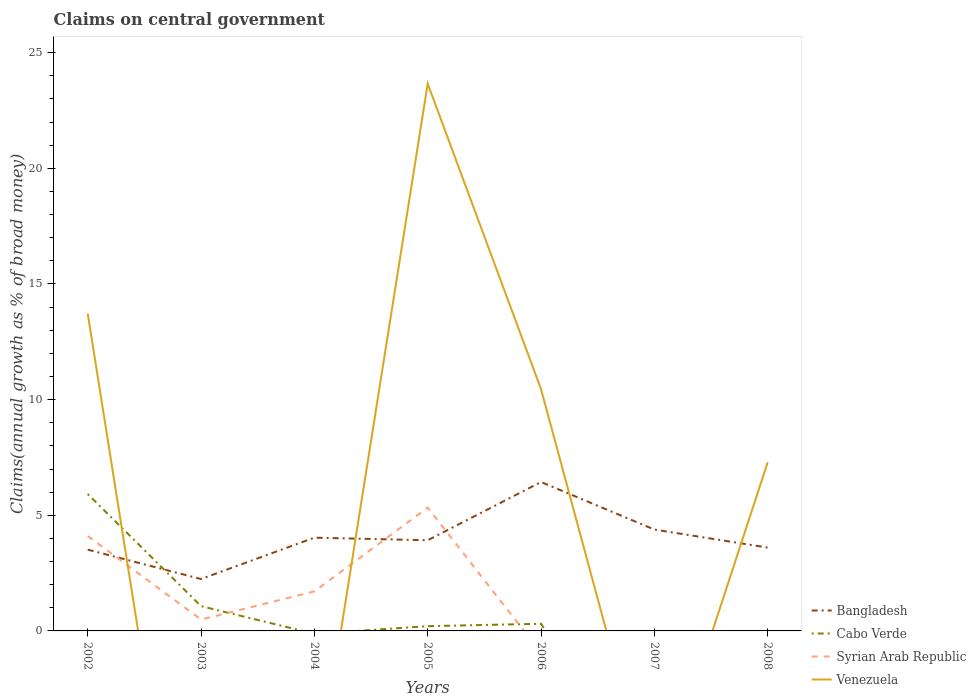How many different coloured lines are there?
Provide a succinct answer. 4. What is the total percentage of broad money claimed on centeral government in Venezuela in the graph?
Provide a succinct answer. 3.16. What is the difference between the highest and the second highest percentage of broad money claimed on centeral government in Venezuela?
Provide a succinct answer. 23.66. What is the difference between the highest and the lowest percentage of broad money claimed on centeral government in Venezuela?
Keep it short and to the point. 3. Is the percentage of broad money claimed on centeral government in Venezuela strictly greater than the percentage of broad money claimed on centeral government in Bangladesh over the years?
Provide a succinct answer. No. How many years are there in the graph?
Offer a terse response. 7. What is the difference between two consecutive major ticks on the Y-axis?
Give a very brief answer. 5. Does the graph contain any zero values?
Offer a terse response. Yes. How many legend labels are there?
Ensure brevity in your answer.  4. How are the legend labels stacked?
Your answer should be very brief. Vertical. What is the title of the graph?
Your response must be concise. Claims on central government. What is the label or title of the Y-axis?
Provide a short and direct response. Claims(annual growth as % of broad money). What is the Claims(annual growth as % of broad money) of Bangladesh in 2002?
Provide a succinct answer. 3.51. What is the Claims(annual growth as % of broad money) in Cabo Verde in 2002?
Your answer should be very brief. 5.92. What is the Claims(annual growth as % of broad money) in Syrian Arab Republic in 2002?
Provide a succinct answer. 4.1. What is the Claims(annual growth as % of broad money) in Venezuela in 2002?
Provide a succinct answer. 13.72. What is the Claims(annual growth as % of broad money) of Bangladesh in 2003?
Provide a succinct answer. 2.24. What is the Claims(annual growth as % of broad money) of Cabo Verde in 2003?
Your response must be concise. 1.07. What is the Claims(annual growth as % of broad money) in Syrian Arab Republic in 2003?
Offer a very short reply. 0.49. What is the Claims(annual growth as % of broad money) of Venezuela in 2003?
Provide a short and direct response. 0. What is the Claims(annual growth as % of broad money) in Bangladesh in 2004?
Provide a succinct answer. 4.03. What is the Claims(annual growth as % of broad money) of Syrian Arab Republic in 2004?
Your answer should be very brief. 1.71. What is the Claims(annual growth as % of broad money) of Venezuela in 2004?
Keep it short and to the point. 0. What is the Claims(annual growth as % of broad money) of Bangladesh in 2005?
Give a very brief answer. 3.92. What is the Claims(annual growth as % of broad money) of Cabo Verde in 2005?
Your answer should be compact. 0.21. What is the Claims(annual growth as % of broad money) in Syrian Arab Republic in 2005?
Provide a succinct answer. 5.33. What is the Claims(annual growth as % of broad money) of Venezuela in 2005?
Ensure brevity in your answer.  23.66. What is the Claims(annual growth as % of broad money) of Bangladesh in 2006?
Offer a terse response. 6.44. What is the Claims(annual growth as % of broad money) of Cabo Verde in 2006?
Provide a succinct answer. 0.31. What is the Claims(annual growth as % of broad money) of Venezuela in 2006?
Offer a very short reply. 10.45. What is the Claims(annual growth as % of broad money) of Bangladesh in 2007?
Your answer should be compact. 4.38. What is the Claims(annual growth as % of broad money) of Cabo Verde in 2007?
Your answer should be compact. 0. What is the Claims(annual growth as % of broad money) in Venezuela in 2007?
Provide a short and direct response. 0. What is the Claims(annual growth as % of broad money) of Bangladesh in 2008?
Make the answer very short. 3.6. What is the Claims(annual growth as % of broad money) in Syrian Arab Republic in 2008?
Your answer should be very brief. 0. What is the Claims(annual growth as % of broad money) of Venezuela in 2008?
Give a very brief answer. 7.29. Across all years, what is the maximum Claims(annual growth as % of broad money) of Bangladesh?
Ensure brevity in your answer.  6.44. Across all years, what is the maximum Claims(annual growth as % of broad money) in Cabo Verde?
Provide a short and direct response. 5.92. Across all years, what is the maximum Claims(annual growth as % of broad money) of Syrian Arab Republic?
Provide a short and direct response. 5.33. Across all years, what is the maximum Claims(annual growth as % of broad money) in Venezuela?
Make the answer very short. 23.66. Across all years, what is the minimum Claims(annual growth as % of broad money) of Bangladesh?
Your answer should be compact. 2.24. Across all years, what is the minimum Claims(annual growth as % of broad money) in Venezuela?
Keep it short and to the point. 0. What is the total Claims(annual growth as % of broad money) in Bangladesh in the graph?
Provide a succinct answer. 28.13. What is the total Claims(annual growth as % of broad money) in Cabo Verde in the graph?
Ensure brevity in your answer.  7.5. What is the total Claims(annual growth as % of broad money) of Syrian Arab Republic in the graph?
Your response must be concise. 11.63. What is the total Claims(annual growth as % of broad money) of Venezuela in the graph?
Keep it short and to the point. 55.12. What is the difference between the Claims(annual growth as % of broad money) in Bangladesh in 2002 and that in 2003?
Provide a succinct answer. 1.27. What is the difference between the Claims(annual growth as % of broad money) in Cabo Verde in 2002 and that in 2003?
Provide a short and direct response. 4.85. What is the difference between the Claims(annual growth as % of broad money) in Syrian Arab Republic in 2002 and that in 2003?
Ensure brevity in your answer.  3.61. What is the difference between the Claims(annual growth as % of broad money) of Bangladesh in 2002 and that in 2004?
Offer a terse response. -0.52. What is the difference between the Claims(annual growth as % of broad money) in Syrian Arab Republic in 2002 and that in 2004?
Your response must be concise. 2.4. What is the difference between the Claims(annual growth as % of broad money) in Bangladesh in 2002 and that in 2005?
Your answer should be very brief. -0.41. What is the difference between the Claims(annual growth as % of broad money) of Cabo Verde in 2002 and that in 2005?
Provide a succinct answer. 5.71. What is the difference between the Claims(annual growth as % of broad money) in Syrian Arab Republic in 2002 and that in 2005?
Your response must be concise. -1.23. What is the difference between the Claims(annual growth as % of broad money) of Venezuela in 2002 and that in 2005?
Offer a very short reply. -9.94. What is the difference between the Claims(annual growth as % of broad money) in Bangladesh in 2002 and that in 2006?
Offer a very short reply. -2.93. What is the difference between the Claims(annual growth as % of broad money) in Cabo Verde in 2002 and that in 2006?
Provide a short and direct response. 5.61. What is the difference between the Claims(annual growth as % of broad money) in Venezuela in 2002 and that in 2006?
Your answer should be compact. 3.27. What is the difference between the Claims(annual growth as % of broad money) of Bangladesh in 2002 and that in 2007?
Ensure brevity in your answer.  -0.87. What is the difference between the Claims(annual growth as % of broad money) in Bangladesh in 2002 and that in 2008?
Give a very brief answer. -0.09. What is the difference between the Claims(annual growth as % of broad money) in Venezuela in 2002 and that in 2008?
Ensure brevity in your answer.  6.43. What is the difference between the Claims(annual growth as % of broad money) in Bangladesh in 2003 and that in 2004?
Ensure brevity in your answer.  -1.79. What is the difference between the Claims(annual growth as % of broad money) in Syrian Arab Republic in 2003 and that in 2004?
Your answer should be very brief. -1.22. What is the difference between the Claims(annual growth as % of broad money) in Bangladesh in 2003 and that in 2005?
Give a very brief answer. -1.68. What is the difference between the Claims(annual growth as % of broad money) in Cabo Verde in 2003 and that in 2005?
Keep it short and to the point. 0.87. What is the difference between the Claims(annual growth as % of broad money) of Syrian Arab Republic in 2003 and that in 2005?
Your answer should be very brief. -4.84. What is the difference between the Claims(annual growth as % of broad money) of Bangladesh in 2003 and that in 2006?
Keep it short and to the point. -4.19. What is the difference between the Claims(annual growth as % of broad money) in Cabo Verde in 2003 and that in 2006?
Keep it short and to the point. 0.76. What is the difference between the Claims(annual growth as % of broad money) in Bangladesh in 2003 and that in 2007?
Ensure brevity in your answer.  -2.14. What is the difference between the Claims(annual growth as % of broad money) in Bangladesh in 2003 and that in 2008?
Provide a succinct answer. -1.36. What is the difference between the Claims(annual growth as % of broad money) in Bangladesh in 2004 and that in 2005?
Keep it short and to the point. 0.11. What is the difference between the Claims(annual growth as % of broad money) in Syrian Arab Republic in 2004 and that in 2005?
Offer a very short reply. -3.62. What is the difference between the Claims(annual growth as % of broad money) of Bangladesh in 2004 and that in 2006?
Provide a short and direct response. -2.41. What is the difference between the Claims(annual growth as % of broad money) in Bangladesh in 2004 and that in 2007?
Offer a very short reply. -0.35. What is the difference between the Claims(annual growth as % of broad money) of Bangladesh in 2004 and that in 2008?
Your answer should be compact. 0.43. What is the difference between the Claims(annual growth as % of broad money) in Bangladesh in 2005 and that in 2006?
Your answer should be very brief. -2.52. What is the difference between the Claims(annual growth as % of broad money) of Cabo Verde in 2005 and that in 2006?
Ensure brevity in your answer.  -0.1. What is the difference between the Claims(annual growth as % of broad money) of Venezuela in 2005 and that in 2006?
Offer a terse response. 13.21. What is the difference between the Claims(annual growth as % of broad money) of Bangladesh in 2005 and that in 2007?
Provide a succinct answer. -0.46. What is the difference between the Claims(annual growth as % of broad money) of Bangladesh in 2005 and that in 2008?
Offer a very short reply. 0.32. What is the difference between the Claims(annual growth as % of broad money) of Venezuela in 2005 and that in 2008?
Keep it short and to the point. 16.36. What is the difference between the Claims(annual growth as % of broad money) of Bangladesh in 2006 and that in 2007?
Keep it short and to the point. 2.06. What is the difference between the Claims(annual growth as % of broad money) of Bangladesh in 2006 and that in 2008?
Keep it short and to the point. 2.84. What is the difference between the Claims(annual growth as % of broad money) of Venezuela in 2006 and that in 2008?
Your answer should be very brief. 3.16. What is the difference between the Claims(annual growth as % of broad money) of Bangladesh in 2007 and that in 2008?
Keep it short and to the point. 0.78. What is the difference between the Claims(annual growth as % of broad money) in Bangladesh in 2002 and the Claims(annual growth as % of broad money) in Cabo Verde in 2003?
Provide a short and direct response. 2.44. What is the difference between the Claims(annual growth as % of broad money) in Bangladesh in 2002 and the Claims(annual growth as % of broad money) in Syrian Arab Republic in 2003?
Provide a short and direct response. 3.02. What is the difference between the Claims(annual growth as % of broad money) of Cabo Verde in 2002 and the Claims(annual growth as % of broad money) of Syrian Arab Republic in 2003?
Make the answer very short. 5.43. What is the difference between the Claims(annual growth as % of broad money) of Bangladesh in 2002 and the Claims(annual growth as % of broad money) of Syrian Arab Republic in 2004?
Offer a terse response. 1.8. What is the difference between the Claims(annual growth as % of broad money) in Cabo Verde in 2002 and the Claims(annual growth as % of broad money) in Syrian Arab Republic in 2004?
Offer a terse response. 4.21. What is the difference between the Claims(annual growth as % of broad money) in Bangladesh in 2002 and the Claims(annual growth as % of broad money) in Cabo Verde in 2005?
Ensure brevity in your answer.  3.31. What is the difference between the Claims(annual growth as % of broad money) in Bangladesh in 2002 and the Claims(annual growth as % of broad money) in Syrian Arab Republic in 2005?
Give a very brief answer. -1.82. What is the difference between the Claims(annual growth as % of broad money) of Bangladesh in 2002 and the Claims(annual growth as % of broad money) of Venezuela in 2005?
Your response must be concise. -20.14. What is the difference between the Claims(annual growth as % of broad money) of Cabo Verde in 2002 and the Claims(annual growth as % of broad money) of Syrian Arab Republic in 2005?
Offer a terse response. 0.59. What is the difference between the Claims(annual growth as % of broad money) in Cabo Verde in 2002 and the Claims(annual growth as % of broad money) in Venezuela in 2005?
Make the answer very short. -17.74. What is the difference between the Claims(annual growth as % of broad money) of Syrian Arab Republic in 2002 and the Claims(annual growth as % of broad money) of Venezuela in 2005?
Provide a short and direct response. -19.55. What is the difference between the Claims(annual growth as % of broad money) of Bangladesh in 2002 and the Claims(annual growth as % of broad money) of Cabo Verde in 2006?
Ensure brevity in your answer.  3.2. What is the difference between the Claims(annual growth as % of broad money) of Bangladesh in 2002 and the Claims(annual growth as % of broad money) of Venezuela in 2006?
Your response must be concise. -6.94. What is the difference between the Claims(annual growth as % of broad money) of Cabo Verde in 2002 and the Claims(annual growth as % of broad money) of Venezuela in 2006?
Ensure brevity in your answer.  -4.53. What is the difference between the Claims(annual growth as % of broad money) of Syrian Arab Republic in 2002 and the Claims(annual growth as % of broad money) of Venezuela in 2006?
Offer a very short reply. -6.35. What is the difference between the Claims(annual growth as % of broad money) in Bangladesh in 2002 and the Claims(annual growth as % of broad money) in Venezuela in 2008?
Provide a succinct answer. -3.78. What is the difference between the Claims(annual growth as % of broad money) of Cabo Verde in 2002 and the Claims(annual growth as % of broad money) of Venezuela in 2008?
Make the answer very short. -1.37. What is the difference between the Claims(annual growth as % of broad money) in Syrian Arab Republic in 2002 and the Claims(annual growth as % of broad money) in Venezuela in 2008?
Your answer should be compact. -3.19. What is the difference between the Claims(annual growth as % of broad money) in Bangladesh in 2003 and the Claims(annual growth as % of broad money) in Syrian Arab Republic in 2004?
Provide a succinct answer. 0.53. What is the difference between the Claims(annual growth as % of broad money) in Cabo Verde in 2003 and the Claims(annual growth as % of broad money) in Syrian Arab Republic in 2004?
Provide a succinct answer. -0.64. What is the difference between the Claims(annual growth as % of broad money) of Bangladesh in 2003 and the Claims(annual growth as % of broad money) of Cabo Verde in 2005?
Offer a very short reply. 2.04. What is the difference between the Claims(annual growth as % of broad money) in Bangladesh in 2003 and the Claims(annual growth as % of broad money) in Syrian Arab Republic in 2005?
Offer a terse response. -3.09. What is the difference between the Claims(annual growth as % of broad money) in Bangladesh in 2003 and the Claims(annual growth as % of broad money) in Venezuela in 2005?
Ensure brevity in your answer.  -21.41. What is the difference between the Claims(annual growth as % of broad money) in Cabo Verde in 2003 and the Claims(annual growth as % of broad money) in Syrian Arab Republic in 2005?
Your answer should be very brief. -4.26. What is the difference between the Claims(annual growth as % of broad money) in Cabo Verde in 2003 and the Claims(annual growth as % of broad money) in Venezuela in 2005?
Your answer should be very brief. -22.59. What is the difference between the Claims(annual growth as % of broad money) in Syrian Arab Republic in 2003 and the Claims(annual growth as % of broad money) in Venezuela in 2005?
Keep it short and to the point. -23.17. What is the difference between the Claims(annual growth as % of broad money) of Bangladesh in 2003 and the Claims(annual growth as % of broad money) of Cabo Verde in 2006?
Ensure brevity in your answer.  1.93. What is the difference between the Claims(annual growth as % of broad money) in Bangladesh in 2003 and the Claims(annual growth as % of broad money) in Venezuela in 2006?
Make the answer very short. -8.21. What is the difference between the Claims(annual growth as % of broad money) of Cabo Verde in 2003 and the Claims(annual growth as % of broad money) of Venezuela in 2006?
Ensure brevity in your answer.  -9.38. What is the difference between the Claims(annual growth as % of broad money) in Syrian Arab Republic in 2003 and the Claims(annual growth as % of broad money) in Venezuela in 2006?
Your answer should be compact. -9.96. What is the difference between the Claims(annual growth as % of broad money) of Bangladesh in 2003 and the Claims(annual growth as % of broad money) of Venezuela in 2008?
Your response must be concise. -5.05. What is the difference between the Claims(annual growth as % of broad money) of Cabo Verde in 2003 and the Claims(annual growth as % of broad money) of Venezuela in 2008?
Your response must be concise. -6.22. What is the difference between the Claims(annual growth as % of broad money) in Syrian Arab Republic in 2003 and the Claims(annual growth as % of broad money) in Venezuela in 2008?
Your answer should be compact. -6.8. What is the difference between the Claims(annual growth as % of broad money) in Bangladesh in 2004 and the Claims(annual growth as % of broad money) in Cabo Verde in 2005?
Your answer should be compact. 3.83. What is the difference between the Claims(annual growth as % of broad money) of Bangladesh in 2004 and the Claims(annual growth as % of broad money) of Syrian Arab Republic in 2005?
Provide a succinct answer. -1.3. What is the difference between the Claims(annual growth as % of broad money) of Bangladesh in 2004 and the Claims(annual growth as % of broad money) of Venezuela in 2005?
Keep it short and to the point. -19.63. What is the difference between the Claims(annual growth as % of broad money) in Syrian Arab Republic in 2004 and the Claims(annual growth as % of broad money) in Venezuela in 2005?
Offer a very short reply. -21.95. What is the difference between the Claims(annual growth as % of broad money) in Bangladesh in 2004 and the Claims(annual growth as % of broad money) in Cabo Verde in 2006?
Provide a short and direct response. 3.72. What is the difference between the Claims(annual growth as % of broad money) in Bangladesh in 2004 and the Claims(annual growth as % of broad money) in Venezuela in 2006?
Give a very brief answer. -6.42. What is the difference between the Claims(annual growth as % of broad money) of Syrian Arab Republic in 2004 and the Claims(annual growth as % of broad money) of Venezuela in 2006?
Provide a succinct answer. -8.74. What is the difference between the Claims(annual growth as % of broad money) in Bangladesh in 2004 and the Claims(annual growth as % of broad money) in Venezuela in 2008?
Your answer should be very brief. -3.26. What is the difference between the Claims(annual growth as % of broad money) of Syrian Arab Republic in 2004 and the Claims(annual growth as % of broad money) of Venezuela in 2008?
Your answer should be compact. -5.58. What is the difference between the Claims(annual growth as % of broad money) of Bangladesh in 2005 and the Claims(annual growth as % of broad money) of Cabo Verde in 2006?
Offer a very short reply. 3.61. What is the difference between the Claims(annual growth as % of broad money) of Bangladesh in 2005 and the Claims(annual growth as % of broad money) of Venezuela in 2006?
Make the answer very short. -6.53. What is the difference between the Claims(annual growth as % of broad money) in Cabo Verde in 2005 and the Claims(annual growth as % of broad money) in Venezuela in 2006?
Your answer should be very brief. -10.25. What is the difference between the Claims(annual growth as % of broad money) in Syrian Arab Republic in 2005 and the Claims(annual growth as % of broad money) in Venezuela in 2006?
Your answer should be compact. -5.12. What is the difference between the Claims(annual growth as % of broad money) of Bangladesh in 2005 and the Claims(annual growth as % of broad money) of Venezuela in 2008?
Provide a succinct answer. -3.37. What is the difference between the Claims(annual growth as % of broad money) in Cabo Verde in 2005 and the Claims(annual growth as % of broad money) in Venezuela in 2008?
Make the answer very short. -7.09. What is the difference between the Claims(annual growth as % of broad money) in Syrian Arab Republic in 2005 and the Claims(annual growth as % of broad money) in Venezuela in 2008?
Give a very brief answer. -1.96. What is the difference between the Claims(annual growth as % of broad money) in Bangladesh in 2006 and the Claims(annual growth as % of broad money) in Venezuela in 2008?
Provide a short and direct response. -0.85. What is the difference between the Claims(annual growth as % of broad money) in Cabo Verde in 2006 and the Claims(annual growth as % of broad money) in Venezuela in 2008?
Your answer should be very brief. -6.98. What is the difference between the Claims(annual growth as % of broad money) in Bangladesh in 2007 and the Claims(annual growth as % of broad money) in Venezuela in 2008?
Give a very brief answer. -2.91. What is the average Claims(annual growth as % of broad money) in Bangladesh per year?
Offer a terse response. 4.02. What is the average Claims(annual growth as % of broad money) in Cabo Verde per year?
Provide a succinct answer. 1.07. What is the average Claims(annual growth as % of broad money) in Syrian Arab Republic per year?
Offer a very short reply. 1.66. What is the average Claims(annual growth as % of broad money) of Venezuela per year?
Make the answer very short. 7.87. In the year 2002, what is the difference between the Claims(annual growth as % of broad money) of Bangladesh and Claims(annual growth as % of broad money) of Cabo Verde?
Provide a short and direct response. -2.4. In the year 2002, what is the difference between the Claims(annual growth as % of broad money) of Bangladesh and Claims(annual growth as % of broad money) of Syrian Arab Republic?
Provide a succinct answer. -0.59. In the year 2002, what is the difference between the Claims(annual growth as % of broad money) in Bangladesh and Claims(annual growth as % of broad money) in Venezuela?
Make the answer very short. -10.21. In the year 2002, what is the difference between the Claims(annual growth as % of broad money) in Cabo Verde and Claims(annual growth as % of broad money) in Syrian Arab Republic?
Make the answer very short. 1.81. In the year 2002, what is the difference between the Claims(annual growth as % of broad money) in Cabo Verde and Claims(annual growth as % of broad money) in Venezuela?
Your answer should be compact. -7.8. In the year 2002, what is the difference between the Claims(annual growth as % of broad money) of Syrian Arab Republic and Claims(annual growth as % of broad money) of Venezuela?
Your response must be concise. -9.62. In the year 2003, what is the difference between the Claims(annual growth as % of broad money) in Bangladesh and Claims(annual growth as % of broad money) in Cabo Verde?
Give a very brief answer. 1.17. In the year 2003, what is the difference between the Claims(annual growth as % of broad money) in Bangladesh and Claims(annual growth as % of broad money) in Syrian Arab Republic?
Ensure brevity in your answer.  1.75. In the year 2003, what is the difference between the Claims(annual growth as % of broad money) of Cabo Verde and Claims(annual growth as % of broad money) of Syrian Arab Republic?
Offer a terse response. 0.58. In the year 2004, what is the difference between the Claims(annual growth as % of broad money) in Bangladesh and Claims(annual growth as % of broad money) in Syrian Arab Republic?
Offer a terse response. 2.32. In the year 2005, what is the difference between the Claims(annual growth as % of broad money) of Bangladesh and Claims(annual growth as % of broad money) of Cabo Verde?
Offer a very short reply. 3.71. In the year 2005, what is the difference between the Claims(annual growth as % of broad money) of Bangladesh and Claims(annual growth as % of broad money) of Syrian Arab Republic?
Provide a short and direct response. -1.41. In the year 2005, what is the difference between the Claims(annual growth as % of broad money) of Bangladesh and Claims(annual growth as % of broad money) of Venezuela?
Keep it short and to the point. -19.74. In the year 2005, what is the difference between the Claims(annual growth as % of broad money) in Cabo Verde and Claims(annual growth as % of broad money) in Syrian Arab Republic?
Keep it short and to the point. -5.13. In the year 2005, what is the difference between the Claims(annual growth as % of broad money) in Cabo Verde and Claims(annual growth as % of broad money) in Venezuela?
Provide a succinct answer. -23.45. In the year 2005, what is the difference between the Claims(annual growth as % of broad money) of Syrian Arab Republic and Claims(annual growth as % of broad money) of Venezuela?
Offer a very short reply. -18.33. In the year 2006, what is the difference between the Claims(annual growth as % of broad money) in Bangladesh and Claims(annual growth as % of broad money) in Cabo Verde?
Your response must be concise. 6.13. In the year 2006, what is the difference between the Claims(annual growth as % of broad money) in Bangladesh and Claims(annual growth as % of broad money) in Venezuela?
Give a very brief answer. -4.01. In the year 2006, what is the difference between the Claims(annual growth as % of broad money) of Cabo Verde and Claims(annual growth as % of broad money) of Venezuela?
Provide a short and direct response. -10.14. In the year 2008, what is the difference between the Claims(annual growth as % of broad money) in Bangladesh and Claims(annual growth as % of broad money) in Venezuela?
Ensure brevity in your answer.  -3.69. What is the ratio of the Claims(annual growth as % of broad money) of Bangladesh in 2002 to that in 2003?
Ensure brevity in your answer.  1.57. What is the ratio of the Claims(annual growth as % of broad money) in Cabo Verde in 2002 to that in 2003?
Ensure brevity in your answer.  5.52. What is the ratio of the Claims(annual growth as % of broad money) in Syrian Arab Republic in 2002 to that in 2003?
Your response must be concise. 8.36. What is the ratio of the Claims(annual growth as % of broad money) of Bangladesh in 2002 to that in 2004?
Provide a succinct answer. 0.87. What is the ratio of the Claims(annual growth as % of broad money) in Syrian Arab Republic in 2002 to that in 2004?
Ensure brevity in your answer.  2.4. What is the ratio of the Claims(annual growth as % of broad money) in Bangladesh in 2002 to that in 2005?
Your answer should be very brief. 0.9. What is the ratio of the Claims(annual growth as % of broad money) in Cabo Verde in 2002 to that in 2005?
Keep it short and to the point. 28.86. What is the ratio of the Claims(annual growth as % of broad money) in Syrian Arab Republic in 2002 to that in 2005?
Provide a succinct answer. 0.77. What is the ratio of the Claims(annual growth as % of broad money) in Venezuela in 2002 to that in 2005?
Offer a very short reply. 0.58. What is the ratio of the Claims(annual growth as % of broad money) of Bangladesh in 2002 to that in 2006?
Provide a succinct answer. 0.55. What is the ratio of the Claims(annual growth as % of broad money) in Cabo Verde in 2002 to that in 2006?
Your answer should be very brief. 19.14. What is the ratio of the Claims(annual growth as % of broad money) in Venezuela in 2002 to that in 2006?
Offer a terse response. 1.31. What is the ratio of the Claims(annual growth as % of broad money) in Bangladesh in 2002 to that in 2007?
Your answer should be very brief. 0.8. What is the ratio of the Claims(annual growth as % of broad money) in Bangladesh in 2002 to that in 2008?
Offer a very short reply. 0.98. What is the ratio of the Claims(annual growth as % of broad money) of Venezuela in 2002 to that in 2008?
Offer a very short reply. 1.88. What is the ratio of the Claims(annual growth as % of broad money) of Bangladesh in 2003 to that in 2004?
Keep it short and to the point. 0.56. What is the ratio of the Claims(annual growth as % of broad money) in Syrian Arab Republic in 2003 to that in 2004?
Your answer should be compact. 0.29. What is the ratio of the Claims(annual growth as % of broad money) in Bangladesh in 2003 to that in 2005?
Provide a short and direct response. 0.57. What is the ratio of the Claims(annual growth as % of broad money) in Cabo Verde in 2003 to that in 2005?
Provide a succinct answer. 5.22. What is the ratio of the Claims(annual growth as % of broad money) of Syrian Arab Republic in 2003 to that in 2005?
Keep it short and to the point. 0.09. What is the ratio of the Claims(annual growth as % of broad money) in Bangladesh in 2003 to that in 2006?
Your response must be concise. 0.35. What is the ratio of the Claims(annual growth as % of broad money) in Cabo Verde in 2003 to that in 2006?
Offer a terse response. 3.46. What is the ratio of the Claims(annual growth as % of broad money) of Bangladesh in 2003 to that in 2007?
Offer a very short reply. 0.51. What is the ratio of the Claims(annual growth as % of broad money) of Bangladesh in 2003 to that in 2008?
Your response must be concise. 0.62. What is the ratio of the Claims(annual growth as % of broad money) in Bangladesh in 2004 to that in 2005?
Your response must be concise. 1.03. What is the ratio of the Claims(annual growth as % of broad money) in Syrian Arab Republic in 2004 to that in 2005?
Your answer should be very brief. 0.32. What is the ratio of the Claims(annual growth as % of broad money) of Bangladesh in 2004 to that in 2006?
Ensure brevity in your answer.  0.63. What is the ratio of the Claims(annual growth as % of broad money) of Bangladesh in 2004 to that in 2008?
Ensure brevity in your answer.  1.12. What is the ratio of the Claims(annual growth as % of broad money) in Bangladesh in 2005 to that in 2006?
Keep it short and to the point. 0.61. What is the ratio of the Claims(annual growth as % of broad money) of Cabo Verde in 2005 to that in 2006?
Your response must be concise. 0.66. What is the ratio of the Claims(annual growth as % of broad money) in Venezuela in 2005 to that in 2006?
Offer a terse response. 2.26. What is the ratio of the Claims(annual growth as % of broad money) of Bangladesh in 2005 to that in 2007?
Your answer should be compact. 0.89. What is the ratio of the Claims(annual growth as % of broad money) in Bangladesh in 2005 to that in 2008?
Ensure brevity in your answer.  1.09. What is the ratio of the Claims(annual growth as % of broad money) in Venezuela in 2005 to that in 2008?
Make the answer very short. 3.24. What is the ratio of the Claims(annual growth as % of broad money) in Bangladesh in 2006 to that in 2007?
Your answer should be compact. 1.47. What is the ratio of the Claims(annual growth as % of broad money) of Bangladesh in 2006 to that in 2008?
Ensure brevity in your answer.  1.79. What is the ratio of the Claims(annual growth as % of broad money) in Venezuela in 2006 to that in 2008?
Your answer should be compact. 1.43. What is the ratio of the Claims(annual growth as % of broad money) of Bangladesh in 2007 to that in 2008?
Your answer should be compact. 1.22. What is the difference between the highest and the second highest Claims(annual growth as % of broad money) of Bangladesh?
Offer a terse response. 2.06. What is the difference between the highest and the second highest Claims(annual growth as % of broad money) in Cabo Verde?
Make the answer very short. 4.85. What is the difference between the highest and the second highest Claims(annual growth as % of broad money) in Syrian Arab Republic?
Provide a succinct answer. 1.23. What is the difference between the highest and the second highest Claims(annual growth as % of broad money) in Venezuela?
Keep it short and to the point. 9.94. What is the difference between the highest and the lowest Claims(annual growth as % of broad money) of Bangladesh?
Make the answer very short. 4.19. What is the difference between the highest and the lowest Claims(annual growth as % of broad money) of Cabo Verde?
Offer a terse response. 5.92. What is the difference between the highest and the lowest Claims(annual growth as % of broad money) of Syrian Arab Republic?
Provide a short and direct response. 5.33. What is the difference between the highest and the lowest Claims(annual growth as % of broad money) in Venezuela?
Keep it short and to the point. 23.66. 